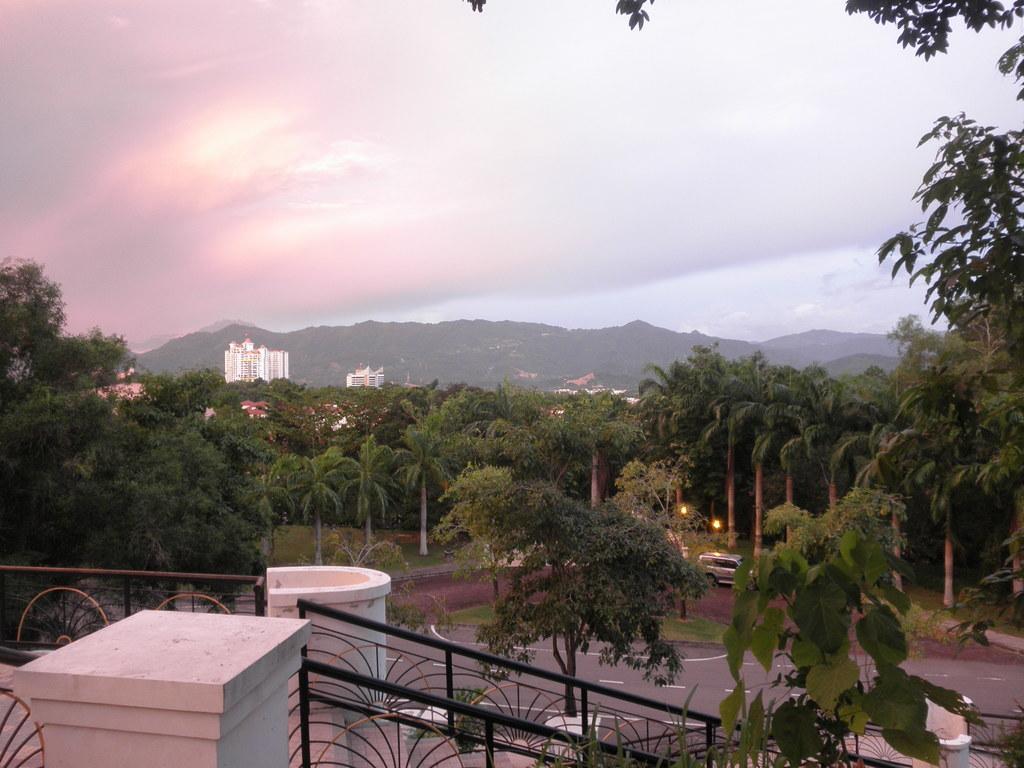Please provide a concise description of this image. In this image, we can see trees, buildings, railing and there is a vehicle on the road. 